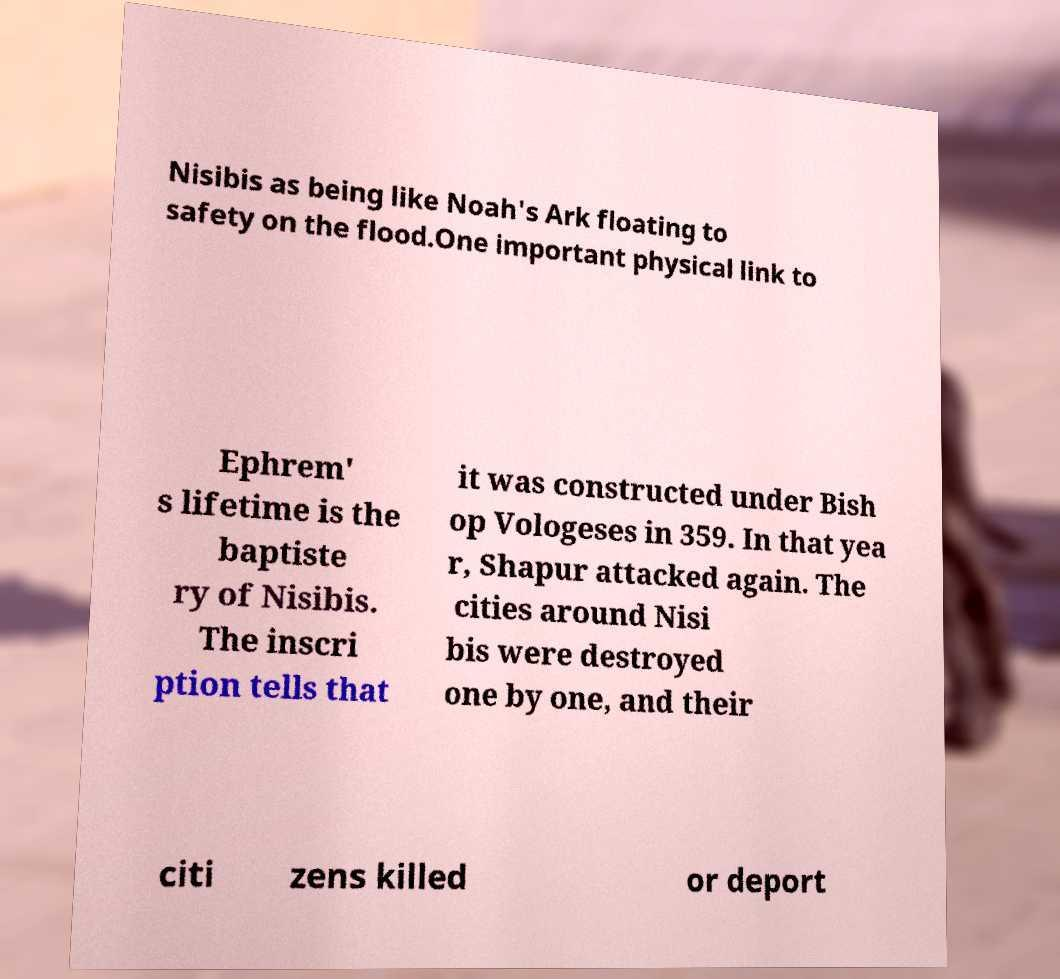What messages or text are displayed in this image? I need them in a readable, typed format. Nisibis as being like Noah's Ark floating to safety on the flood.One important physical link to Ephrem' s lifetime is the baptiste ry of Nisibis. The inscri ption tells that it was constructed under Bish op Vologeses in 359. In that yea r, Shapur attacked again. The cities around Nisi bis were destroyed one by one, and their citi zens killed or deport 